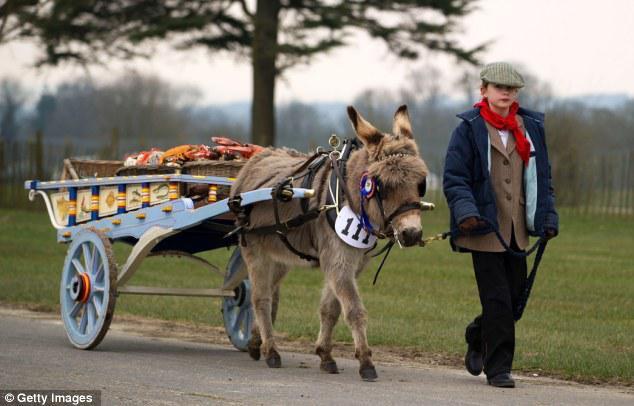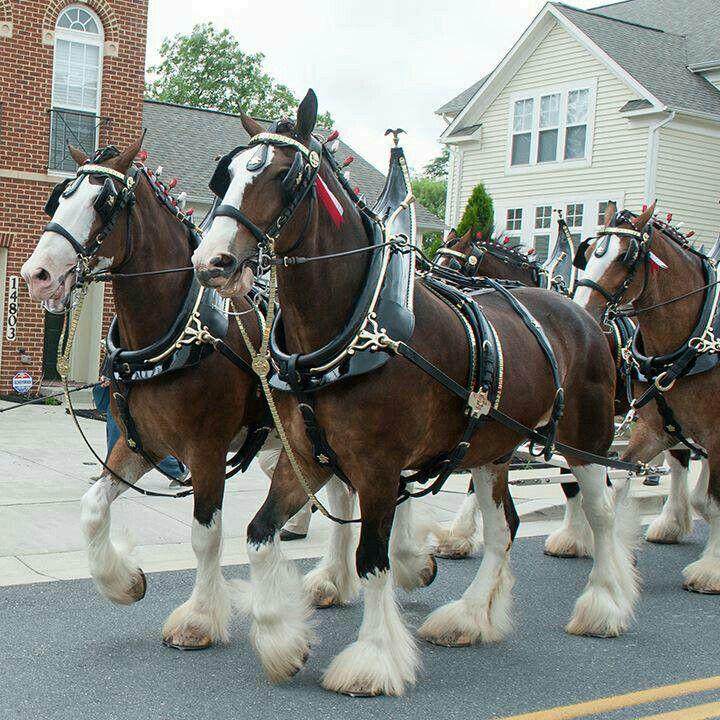The first image is the image on the left, the second image is the image on the right. Evaluate the accuracy of this statement regarding the images: "The horses in the image on the right have furry feet.". Is it true? Answer yes or no. Yes. The first image is the image on the left, the second image is the image on the right. Given the left and right images, does the statement "An image shows a cart pulled by two Clydesdale horses only." hold true? Answer yes or no. No. 